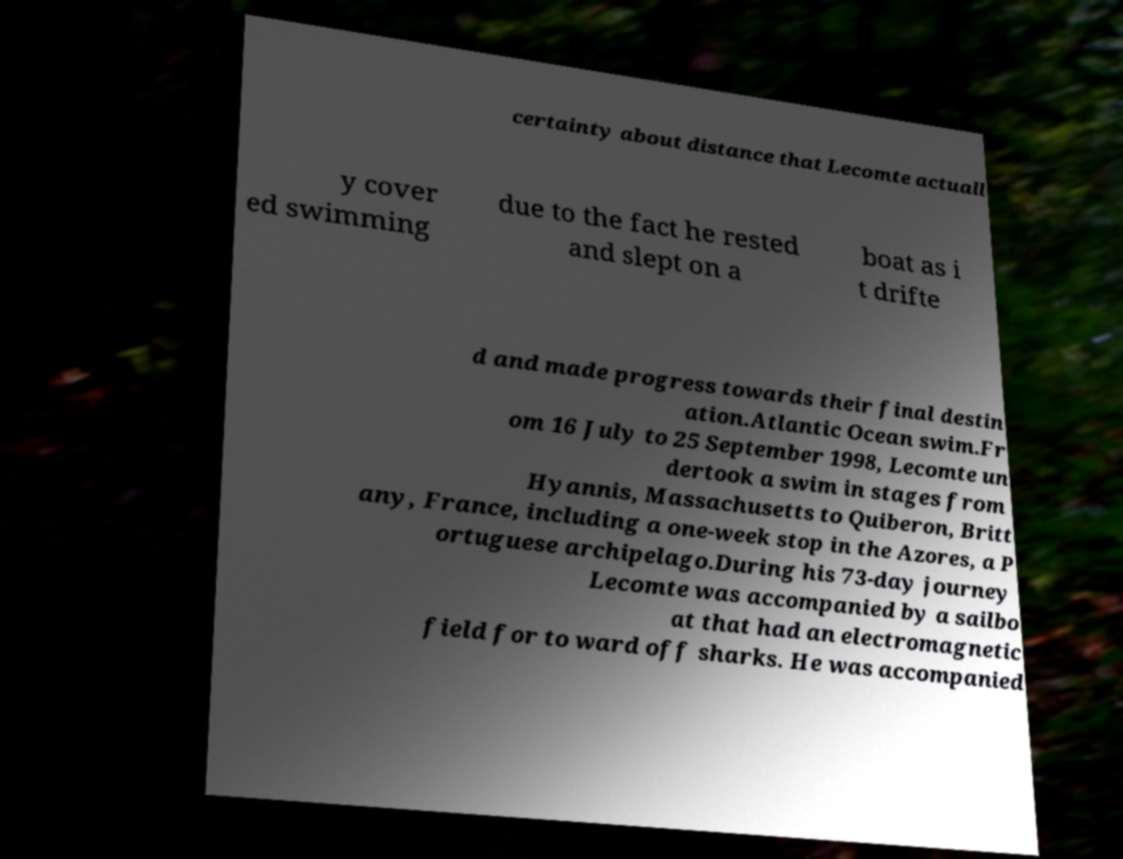Please read and relay the text visible in this image. What does it say? certainty about distance that Lecomte actuall y cover ed swimming due to the fact he rested and slept on a boat as i t drifte d and made progress towards their final destin ation.Atlantic Ocean swim.Fr om 16 July to 25 September 1998, Lecomte un dertook a swim in stages from Hyannis, Massachusetts to Quiberon, Britt any, France, including a one-week stop in the Azores, a P ortuguese archipelago.During his 73-day journey Lecomte was accompanied by a sailbo at that had an electromagnetic field for to ward off sharks. He was accompanied 